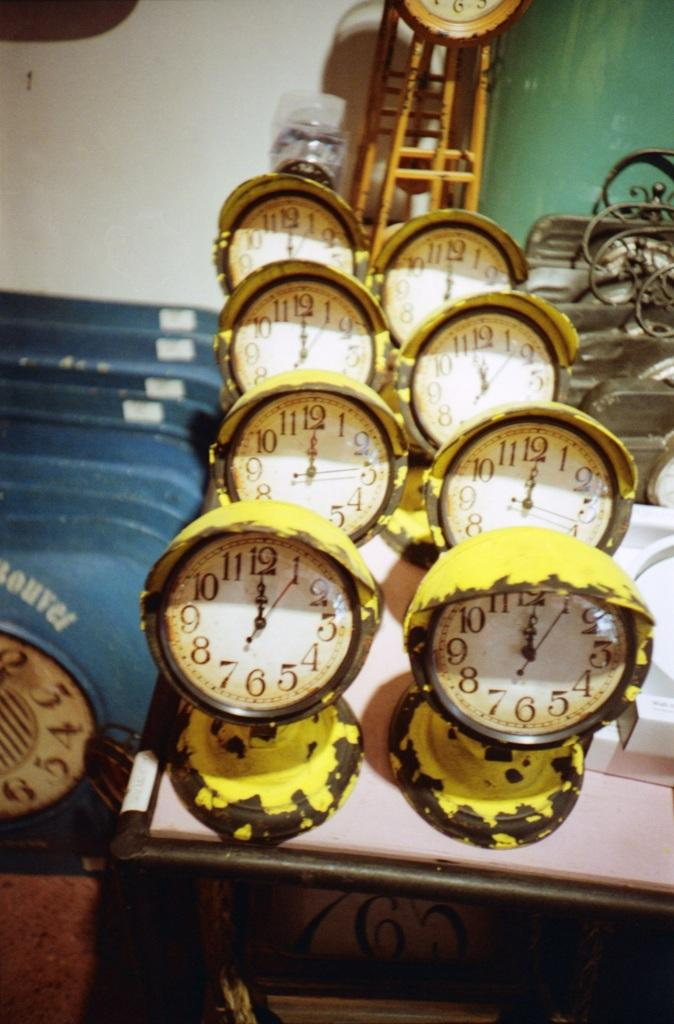<image>
Give a short and clear explanation of the subsequent image. A table of matching yellow and black clocks are almost all set for 12. 